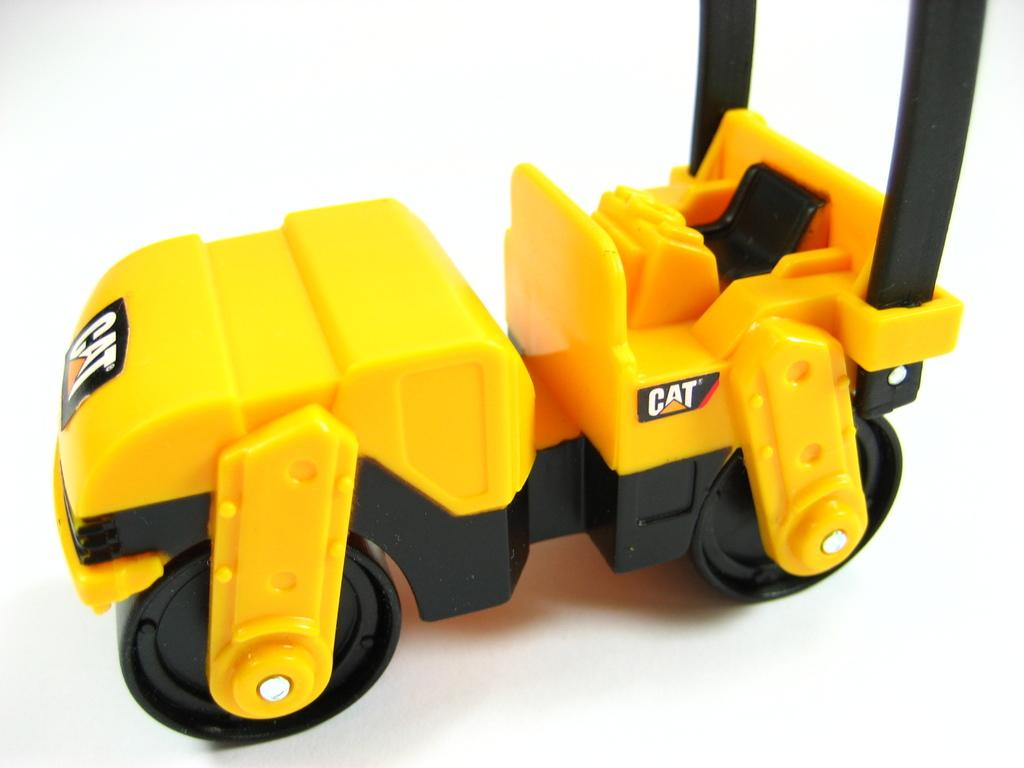What type of toy is present in the image? There is a toy Lego car in the image. Can you describe the toy in more detail? The toy is a Lego car, which is a small model car made of interlocking plastic bricks. What type of pies can be seen in the image? There are no pies present in the image; it features a toy Lego car. 